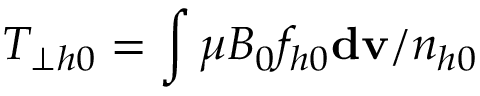Convert formula to latex. <formula><loc_0><loc_0><loc_500><loc_500>T _ { \perp h 0 } = \int \mu B _ { 0 } f _ { h 0 } d v / n _ { h 0 }</formula> 